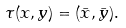<formula> <loc_0><loc_0><loc_500><loc_500>\tau ( x , y ) = ( \bar { x } , \bar { y } ) .</formula> 